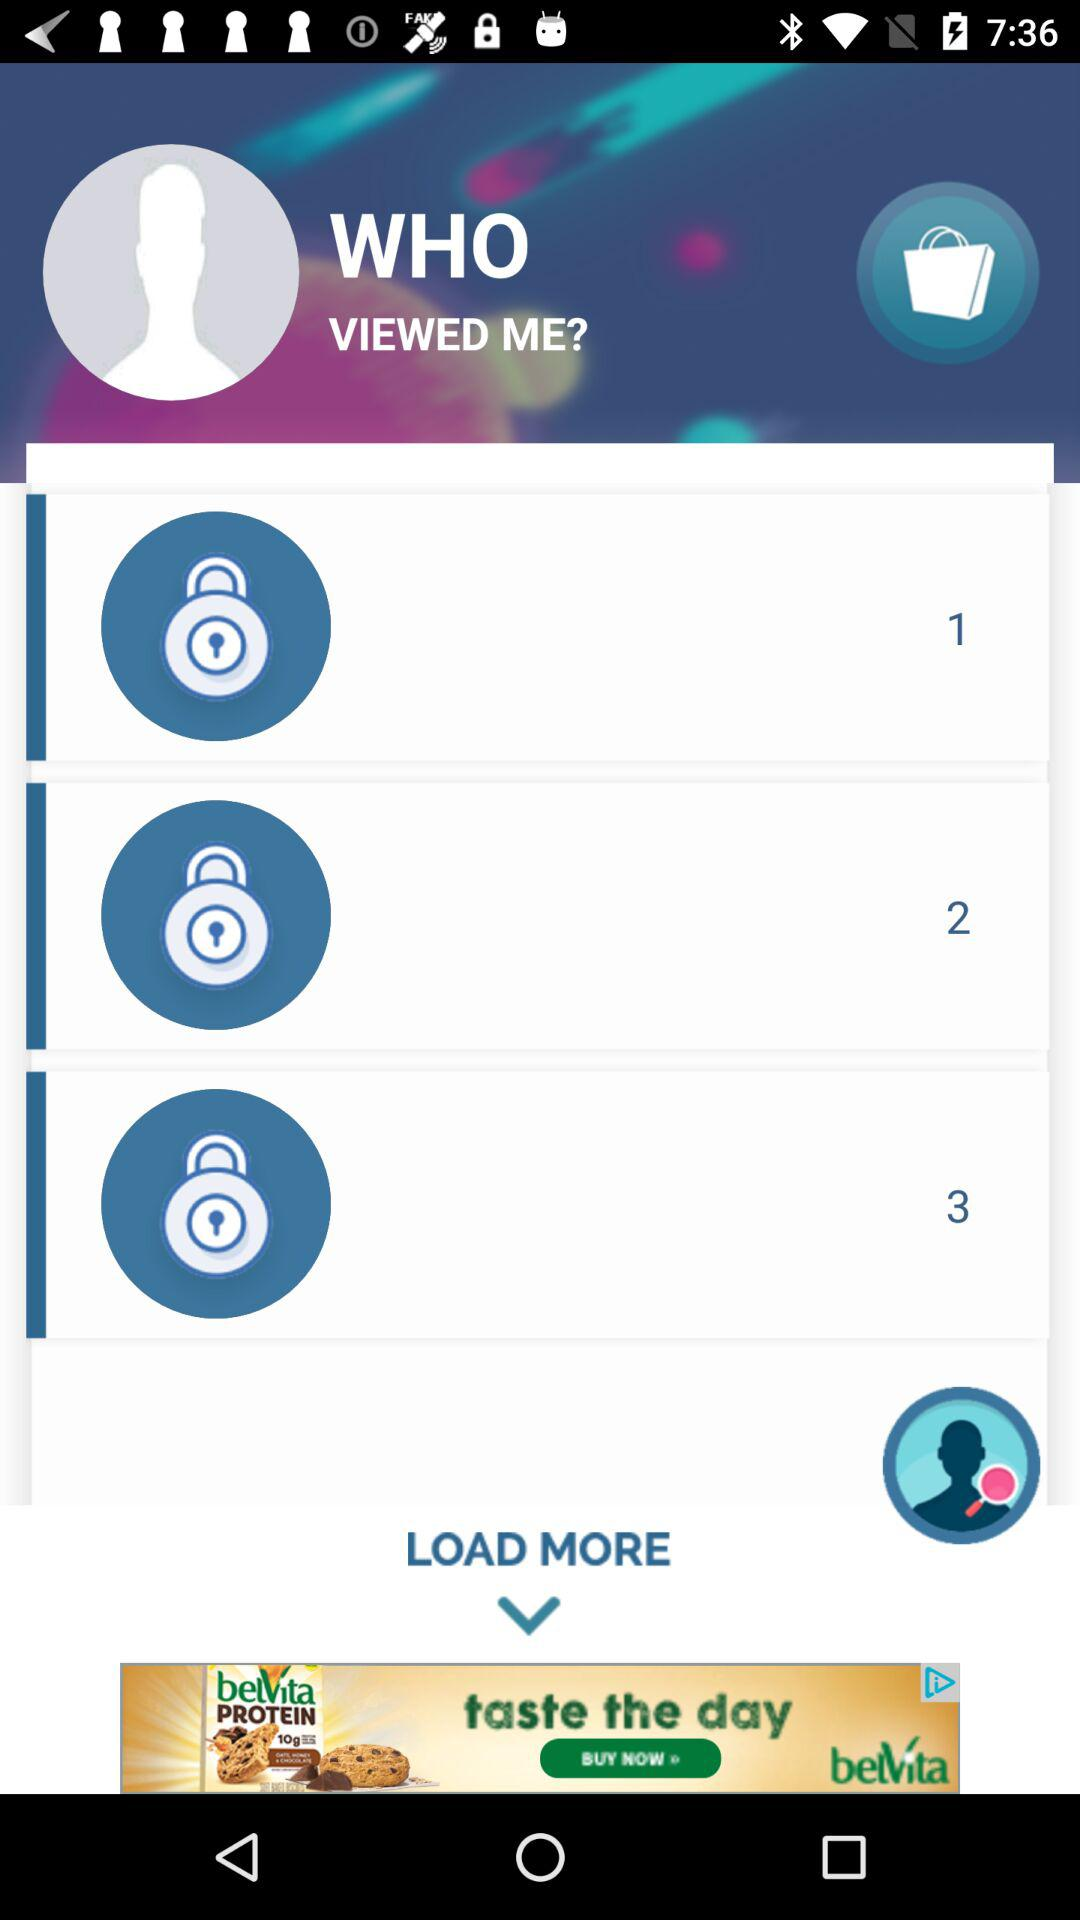How many people viewed me?
Answer the question using a single word or phrase. 3 